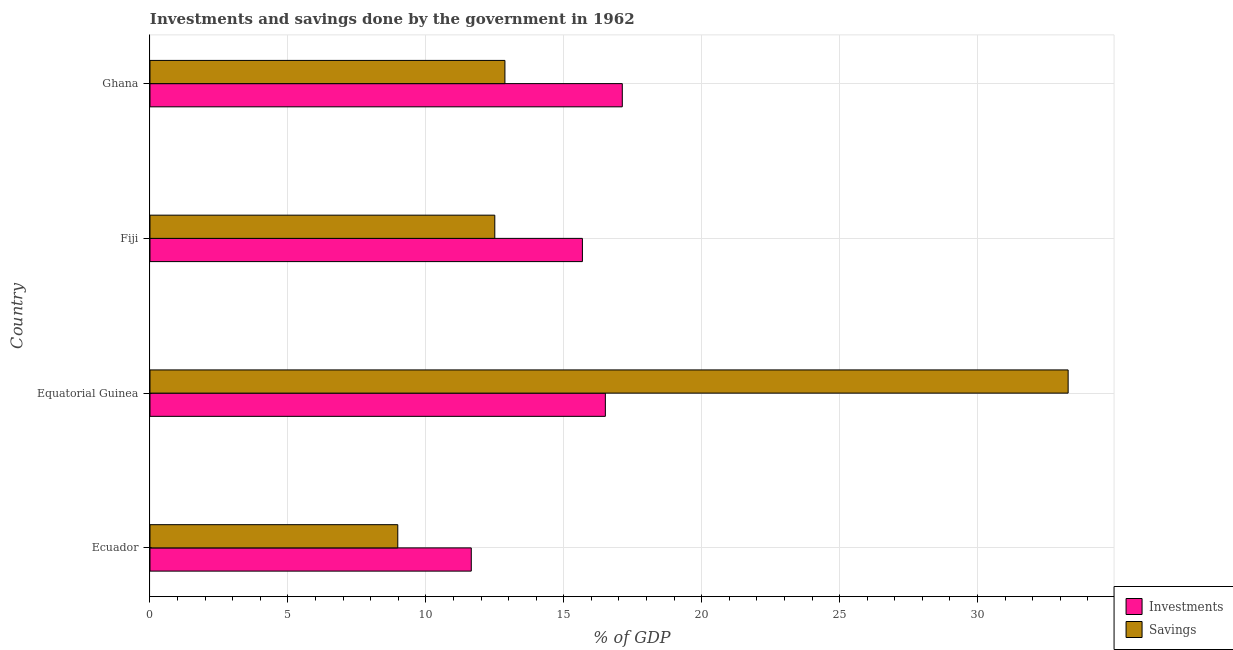How many different coloured bars are there?
Your answer should be very brief. 2. How many groups of bars are there?
Give a very brief answer. 4. Are the number of bars on each tick of the Y-axis equal?
Give a very brief answer. Yes. How many bars are there on the 2nd tick from the top?
Offer a very short reply. 2. What is the label of the 2nd group of bars from the top?
Your answer should be very brief. Fiji. Across all countries, what is the maximum savings of government?
Offer a very short reply. 33.29. Across all countries, what is the minimum savings of government?
Keep it short and to the point. 8.98. In which country was the savings of government minimum?
Ensure brevity in your answer.  Ecuador. What is the total investments of government in the graph?
Provide a short and direct response. 60.95. What is the difference between the investments of government in Ecuador and that in Equatorial Guinea?
Give a very brief answer. -4.86. What is the difference between the savings of government in Ecuador and the investments of government in Equatorial Guinea?
Make the answer very short. -7.53. What is the average investments of government per country?
Make the answer very short. 15.24. What is the difference between the savings of government and investments of government in Ecuador?
Your answer should be very brief. -2.66. What is the ratio of the investments of government in Ecuador to that in Fiji?
Offer a very short reply. 0.74. Is the savings of government in Fiji less than that in Ghana?
Provide a succinct answer. Yes. Is the difference between the investments of government in Equatorial Guinea and Ghana greater than the difference between the savings of government in Equatorial Guinea and Ghana?
Offer a terse response. No. What is the difference between the highest and the second highest savings of government?
Offer a terse response. 20.42. What is the difference between the highest and the lowest investments of government?
Offer a very short reply. 5.48. What does the 1st bar from the top in Ghana represents?
Offer a terse response. Savings. What does the 2nd bar from the bottom in Ecuador represents?
Give a very brief answer. Savings. Are all the bars in the graph horizontal?
Your response must be concise. Yes. How many countries are there in the graph?
Your answer should be compact. 4. What is the difference between two consecutive major ticks on the X-axis?
Offer a terse response. 5. Are the values on the major ticks of X-axis written in scientific E-notation?
Give a very brief answer. No. Does the graph contain any zero values?
Give a very brief answer. No. Does the graph contain grids?
Make the answer very short. Yes. How many legend labels are there?
Offer a terse response. 2. What is the title of the graph?
Make the answer very short. Investments and savings done by the government in 1962. What is the label or title of the X-axis?
Your answer should be very brief. % of GDP. What is the label or title of the Y-axis?
Keep it short and to the point. Country. What is the % of GDP of Investments in Ecuador?
Your answer should be very brief. 11.65. What is the % of GDP in Savings in Ecuador?
Keep it short and to the point. 8.98. What is the % of GDP of Investments in Equatorial Guinea?
Give a very brief answer. 16.51. What is the % of GDP of Savings in Equatorial Guinea?
Make the answer very short. 33.29. What is the % of GDP in Investments in Fiji?
Offer a terse response. 15.68. What is the % of GDP in Savings in Fiji?
Provide a short and direct response. 12.5. What is the % of GDP of Investments in Ghana?
Keep it short and to the point. 17.12. What is the % of GDP in Savings in Ghana?
Offer a very short reply. 12.87. Across all countries, what is the maximum % of GDP in Investments?
Provide a short and direct response. 17.12. Across all countries, what is the maximum % of GDP of Savings?
Offer a terse response. 33.29. Across all countries, what is the minimum % of GDP of Investments?
Your response must be concise. 11.65. Across all countries, what is the minimum % of GDP of Savings?
Give a very brief answer. 8.98. What is the total % of GDP in Investments in the graph?
Offer a terse response. 60.95. What is the total % of GDP in Savings in the graph?
Your answer should be very brief. 67.64. What is the difference between the % of GDP of Investments in Ecuador and that in Equatorial Guinea?
Your answer should be very brief. -4.86. What is the difference between the % of GDP of Savings in Ecuador and that in Equatorial Guinea?
Offer a very short reply. -24.3. What is the difference between the % of GDP in Investments in Ecuador and that in Fiji?
Offer a very short reply. -4.03. What is the difference between the % of GDP of Savings in Ecuador and that in Fiji?
Your answer should be compact. -3.52. What is the difference between the % of GDP of Investments in Ecuador and that in Ghana?
Provide a succinct answer. -5.48. What is the difference between the % of GDP of Savings in Ecuador and that in Ghana?
Your response must be concise. -3.88. What is the difference between the % of GDP in Investments in Equatorial Guinea and that in Fiji?
Your answer should be very brief. 0.83. What is the difference between the % of GDP in Savings in Equatorial Guinea and that in Fiji?
Offer a very short reply. 20.79. What is the difference between the % of GDP in Investments in Equatorial Guinea and that in Ghana?
Offer a very short reply. -0.61. What is the difference between the % of GDP in Savings in Equatorial Guinea and that in Ghana?
Make the answer very short. 20.42. What is the difference between the % of GDP in Investments in Fiji and that in Ghana?
Ensure brevity in your answer.  -1.45. What is the difference between the % of GDP of Savings in Fiji and that in Ghana?
Provide a succinct answer. -0.37. What is the difference between the % of GDP of Investments in Ecuador and the % of GDP of Savings in Equatorial Guinea?
Ensure brevity in your answer.  -21.64. What is the difference between the % of GDP of Investments in Ecuador and the % of GDP of Savings in Fiji?
Ensure brevity in your answer.  -0.85. What is the difference between the % of GDP in Investments in Ecuador and the % of GDP in Savings in Ghana?
Keep it short and to the point. -1.22. What is the difference between the % of GDP of Investments in Equatorial Guinea and the % of GDP of Savings in Fiji?
Provide a short and direct response. 4.01. What is the difference between the % of GDP of Investments in Equatorial Guinea and the % of GDP of Savings in Ghana?
Provide a short and direct response. 3.64. What is the difference between the % of GDP in Investments in Fiji and the % of GDP in Savings in Ghana?
Your answer should be compact. 2.81. What is the average % of GDP of Investments per country?
Make the answer very short. 15.24. What is the average % of GDP in Savings per country?
Your answer should be compact. 16.91. What is the difference between the % of GDP in Investments and % of GDP in Savings in Ecuador?
Your response must be concise. 2.66. What is the difference between the % of GDP in Investments and % of GDP in Savings in Equatorial Guinea?
Keep it short and to the point. -16.78. What is the difference between the % of GDP in Investments and % of GDP in Savings in Fiji?
Offer a very short reply. 3.18. What is the difference between the % of GDP in Investments and % of GDP in Savings in Ghana?
Provide a short and direct response. 4.26. What is the ratio of the % of GDP in Investments in Ecuador to that in Equatorial Guinea?
Your answer should be very brief. 0.71. What is the ratio of the % of GDP of Savings in Ecuador to that in Equatorial Guinea?
Provide a succinct answer. 0.27. What is the ratio of the % of GDP in Investments in Ecuador to that in Fiji?
Keep it short and to the point. 0.74. What is the ratio of the % of GDP of Savings in Ecuador to that in Fiji?
Your answer should be very brief. 0.72. What is the ratio of the % of GDP in Investments in Ecuador to that in Ghana?
Make the answer very short. 0.68. What is the ratio of the % of GDP of Savings in Ecuador to that in Ghana?
Give a very brief answer. 0.7. What is the ratio of the % of GDP in Investments in Equatorial Guinea to that in Fiji?
Make the answer very short. 1.05. What is the ratio of the % of GDP of Savings in Equatorial Guinea to that in Fiji?
Your response must be concise. 2.66. What is the ratio of the % of GDP in Investments in Equatorial Guinea to that in Ghana?
Offer a very short reply. 0.96. What is the ratio of the % of GDP in Savings in Equatorial Guinea to that in Ghana?
Your answer should be compact. 2.59. What is the ratio of the % of GDP of Investments in Fiji to that in Ghana?
Offer a terse response. 0.92. What is the ratio of the % of GDP in Savings in Fiji to that in Ghana?
Provide a succinct answer. 0.97. What is the difference between the highest and the second highest % of GDP in Investments?
Provide a succinct answer. 0.61. What is the difference between the highest and the second highest % of GDP of Savings?
Give a very brief answer. 20.42. What is the difference between the highest and the lowest % of GDP in Investments?
Provide a succinct answer. 5.48. What is the difference between the highest and the lowest % of GDP of Savings?
Provide a short and direct response. 24.3. 